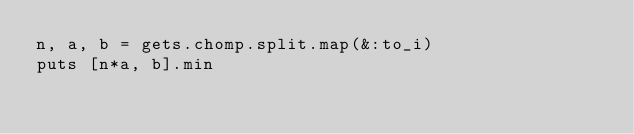<code> <loc_0><loc_0><loc_500><loc_500><_Ruby_>n, a, b = gets.chomp.split.map(&:to_i)
puts [n*a, b].min</code> 